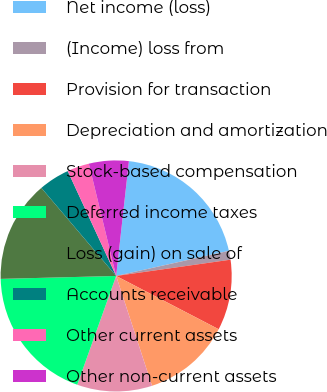Convert chart to OTSL. <chart><loc_0><loc_0><loc_500><loc_500><pie_chart><fcel>Net income (loss)<fcel>(Income) loss from<fcel>Provision for transaction<fcel>Depreciation and amortization<fcel>Stock-based compensation<fcel>Deferred income taxes<fcel>Loss (gain) on sale of<fcel>Accounts receivable<fcel>Other current assets<fcel>Other non-current assets<nl><fcel>19.75%<fcel>1.24%<fcel>9.88%<fcel>12.35%<fcel>10.49%<fcel>19.13%<fcel>14.2%<fcel>4.32%<fcel>3.09%<fcel>5.56%<nl></chart> 